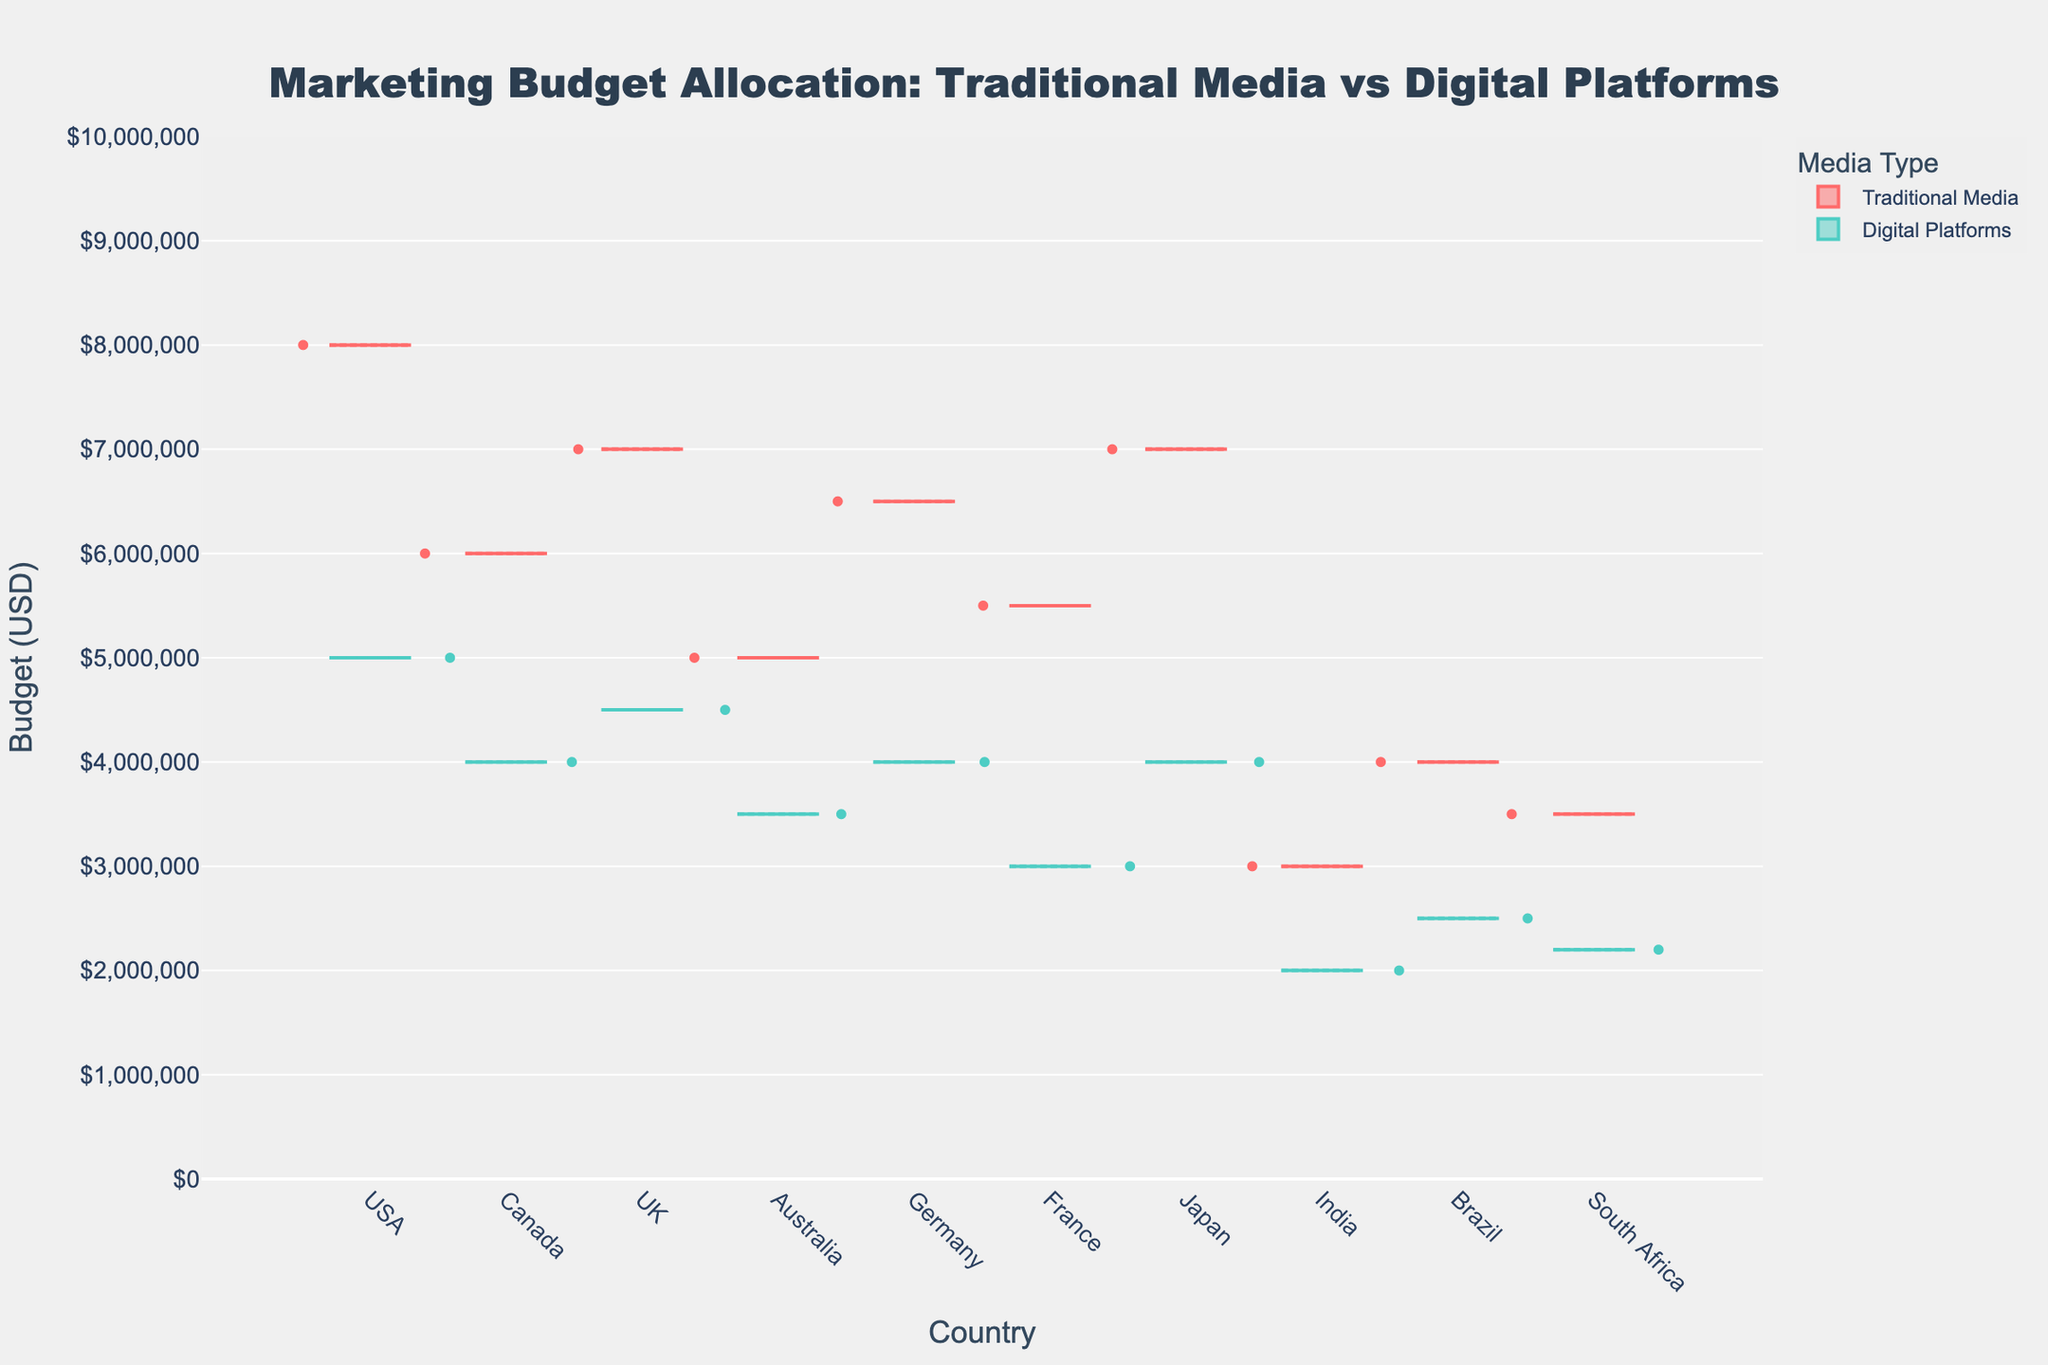What's the title of the figure? The title is prominently displayed at the top of the figure and is centered.
Answer: Marketing Budget Allocation: Traditional Media vs Digital Platforms Which media type has the highest median budget for the USA? Examine the central line inside the Traditional Media and Digital Platforms boxes for the USA, which represents the median.
Answer: Traditional Media How many countries allocate more budget to Digital Platforms than Traditional Media? Compare the budget boxes for each country and count how many times the Digital Platforms' budget appears higher than the Traditional Media's budget.
Answer: 0 What is the approximate budget range for Digital Platforms in Canada? Look at the bottom and top of the box for Digital Platforms in Canada to determine the minimum and maximum values.
Answer: $4,000,000 - $6,000,000 Which country has the lowest budget for Traditional Media? Identify the countries on the x-axis and compare the budgets represented by the height of the Traditional Media boxes.
Answer: India How do the marketing budgets in Japan compare between Traditional Media and Digital Platforms? Compare the position of the boxes for Japan: Traditional Media and Digital Platforms, looking at their medians and ranges.
Answer: Traditional Media has a higher budget than Digital Platforms What is the approximate interquartile range (IQR) for Traditional Media in France? The IQR is the distance between the top and bottom of the box for Traditional Media in France, representing the middle 50% of the data.
Answer: Approximately $2,500,000 Which country shows a similar budget allocation between Traditional Media and Digital Platforms? Look for countries where the two boxes (Traditional Media and Digital Platforms) are relatively similar in height and range.
Answer: Japan What is the mean budget allocation for Digital Platforms in Germany? Observe the average line inside the Digital Platforms box for Germany.
Answer: $4,000,000 Which country has the largest difference in budget allocation between Traditional Media and Digital Platforms? Calculate the difference between the top of the boxes for both media types across the countries and identify the largest gap.
Answer: USA 